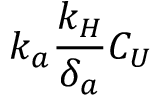Convert formula to latex. <formula><loc_0><loc_0><loc_500><loc_500>k _ { a } \frac { k _ { H } } { \delta _ { a } } C _ { U }</formula> 